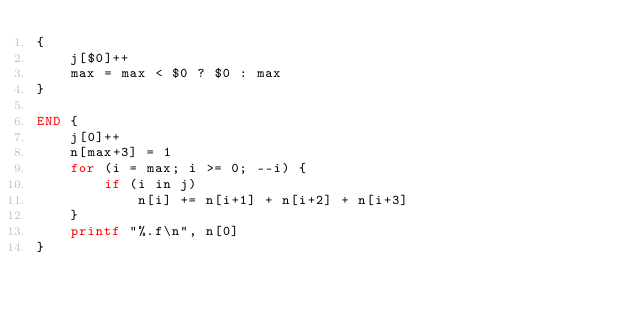Convert code to text. <code><loc_0><loc_0><loc_500><loc_500><_Awk_>{
    j[$0]++
    max = max < $0 ? $0 : max
}

END {
    j[0]++
    n[max+3] = 1
    for (i = max; i >= 0; --i) {
        if (i in j)
            n[i] += n[i+1] + n[i+2] + n[i+3]
    }
    printf "%.f\n", n[0]
}
</code> 